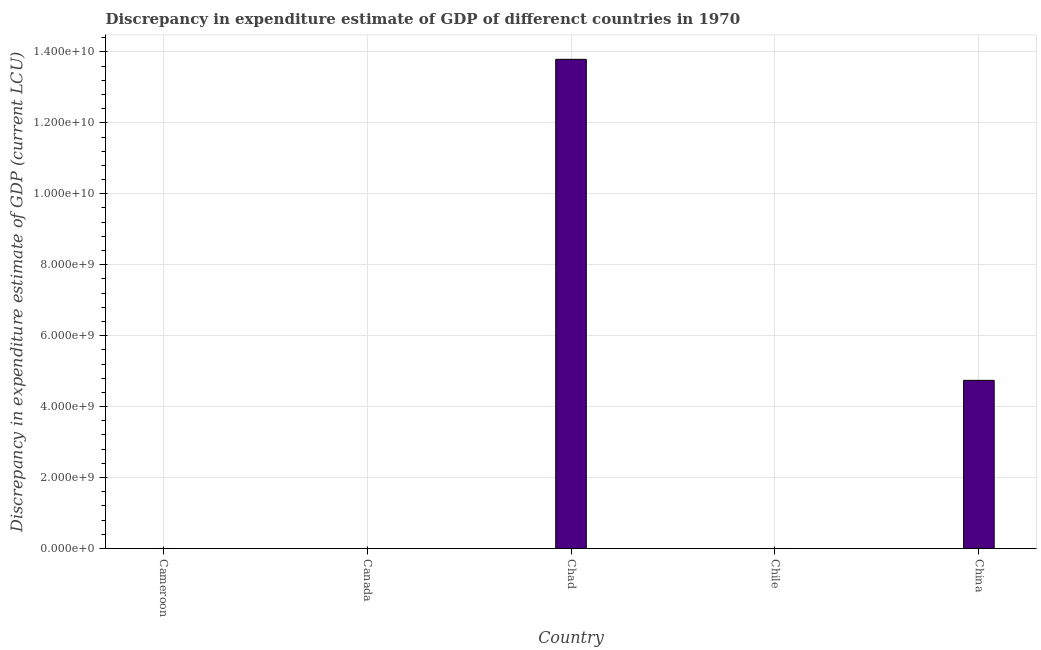Does the graph contain any zero values?
Offer a terse response. Yes. What is the title of the graph?
Give a very brief answer. Discrepancy in expenditure estimate of GDP of differenct countries in 1970. What is the label or title of the Y-axis?
Offer a very short reply. Discrepancy in expenditure estimate of GDP (current LCU). Across all countries, what is the maximum discrepancy in expenditure estimate of gdp?
Ensure brevity in your answer.  1.38e+1. Across all countries, what is the minimum discrepancy in expenditure estimate of gdp?
Make the answer very short. 0. In which country was the discrepancy in expenditure estimate of gdp maximum?
Offer a terse response. Chad. What is the sum of the discrepancy in expenditure estimate of gdp?
Your response must be concise. 1.85e+1. What is the difference between the discrepancy in expenditure estimate of gdp in Chad and China?
Ensure brevity in your answer.  9.05e+09. What is the average discrepancy in expenditure estimate of gdp per country?
Ensure brevity in your answer.  3.71e+09. What is the ratio of the discrepancy in expenditure estimate of gdp in Chad to that in China?
Your response must be concise. 2.91. What is the difference between the highest and the lowest discrepancy in expenditure estimate of gdp?
Provide a succinct answer. 1.38e+1. In how many countries, is the discrepancy in expenditure estimate of gdp greater than the average discrepancy in expenditure estimate of gdp taken over all countries?
Offer a very short reply. 2. Are all the bars in the graph horizontal?
Your answer should be compact. No. What is the difference between two consecutive major ticks on the Y-axis?
Make the answer very short. 2.00e+09. Are the values on the major ticks of Y-axis written in scientific E-notation?
Ensure brevity in your answer.  Yes. What is the Discrepancy in expenditure estimate of GDP (current LCU) in Cameroon?
Your response must be concise. 0. What is the Discrepancy in expenditure estimate of GDP (current LCU) of Chad?
Offer a very short reply. 1.38e+1. What is the Discrepancy in expenditure estimate of GDP (current LCU) of Chile?
Your answer should be very brief. 0. What is the Discrepancy in expenditure estimate of GDP (current LCU) in China?
Offer a very short reply. 4.74e+09. What is the difference between the Discrepancy in expenditure estimate of GDP (current LCU) in Chad and China?
Provide a short and direct response. 9.05e+09. What is the ratio of the Discrepancy in expenditure estimate of GDP (current LCU) in Chad to that in China?
Your answer should be compact. 2.91. 